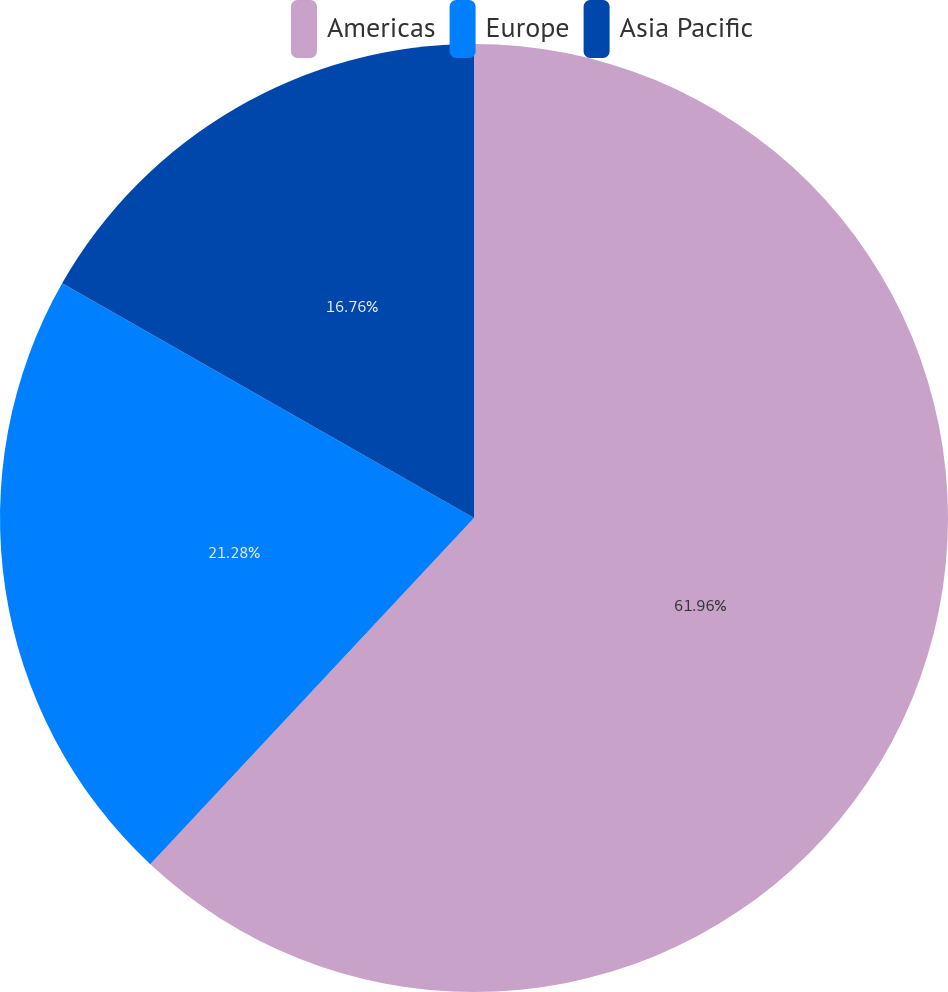Convert chart to OTSL. <chart><loc_0><loc_0><loc_500><loc_500><pie_chart><fcel>Americas<fcel>Europe<fcel>Asia Pacific<nl><fcel>61.97%<fcel>21.28%<fcel>16.76%<nl></chart> 